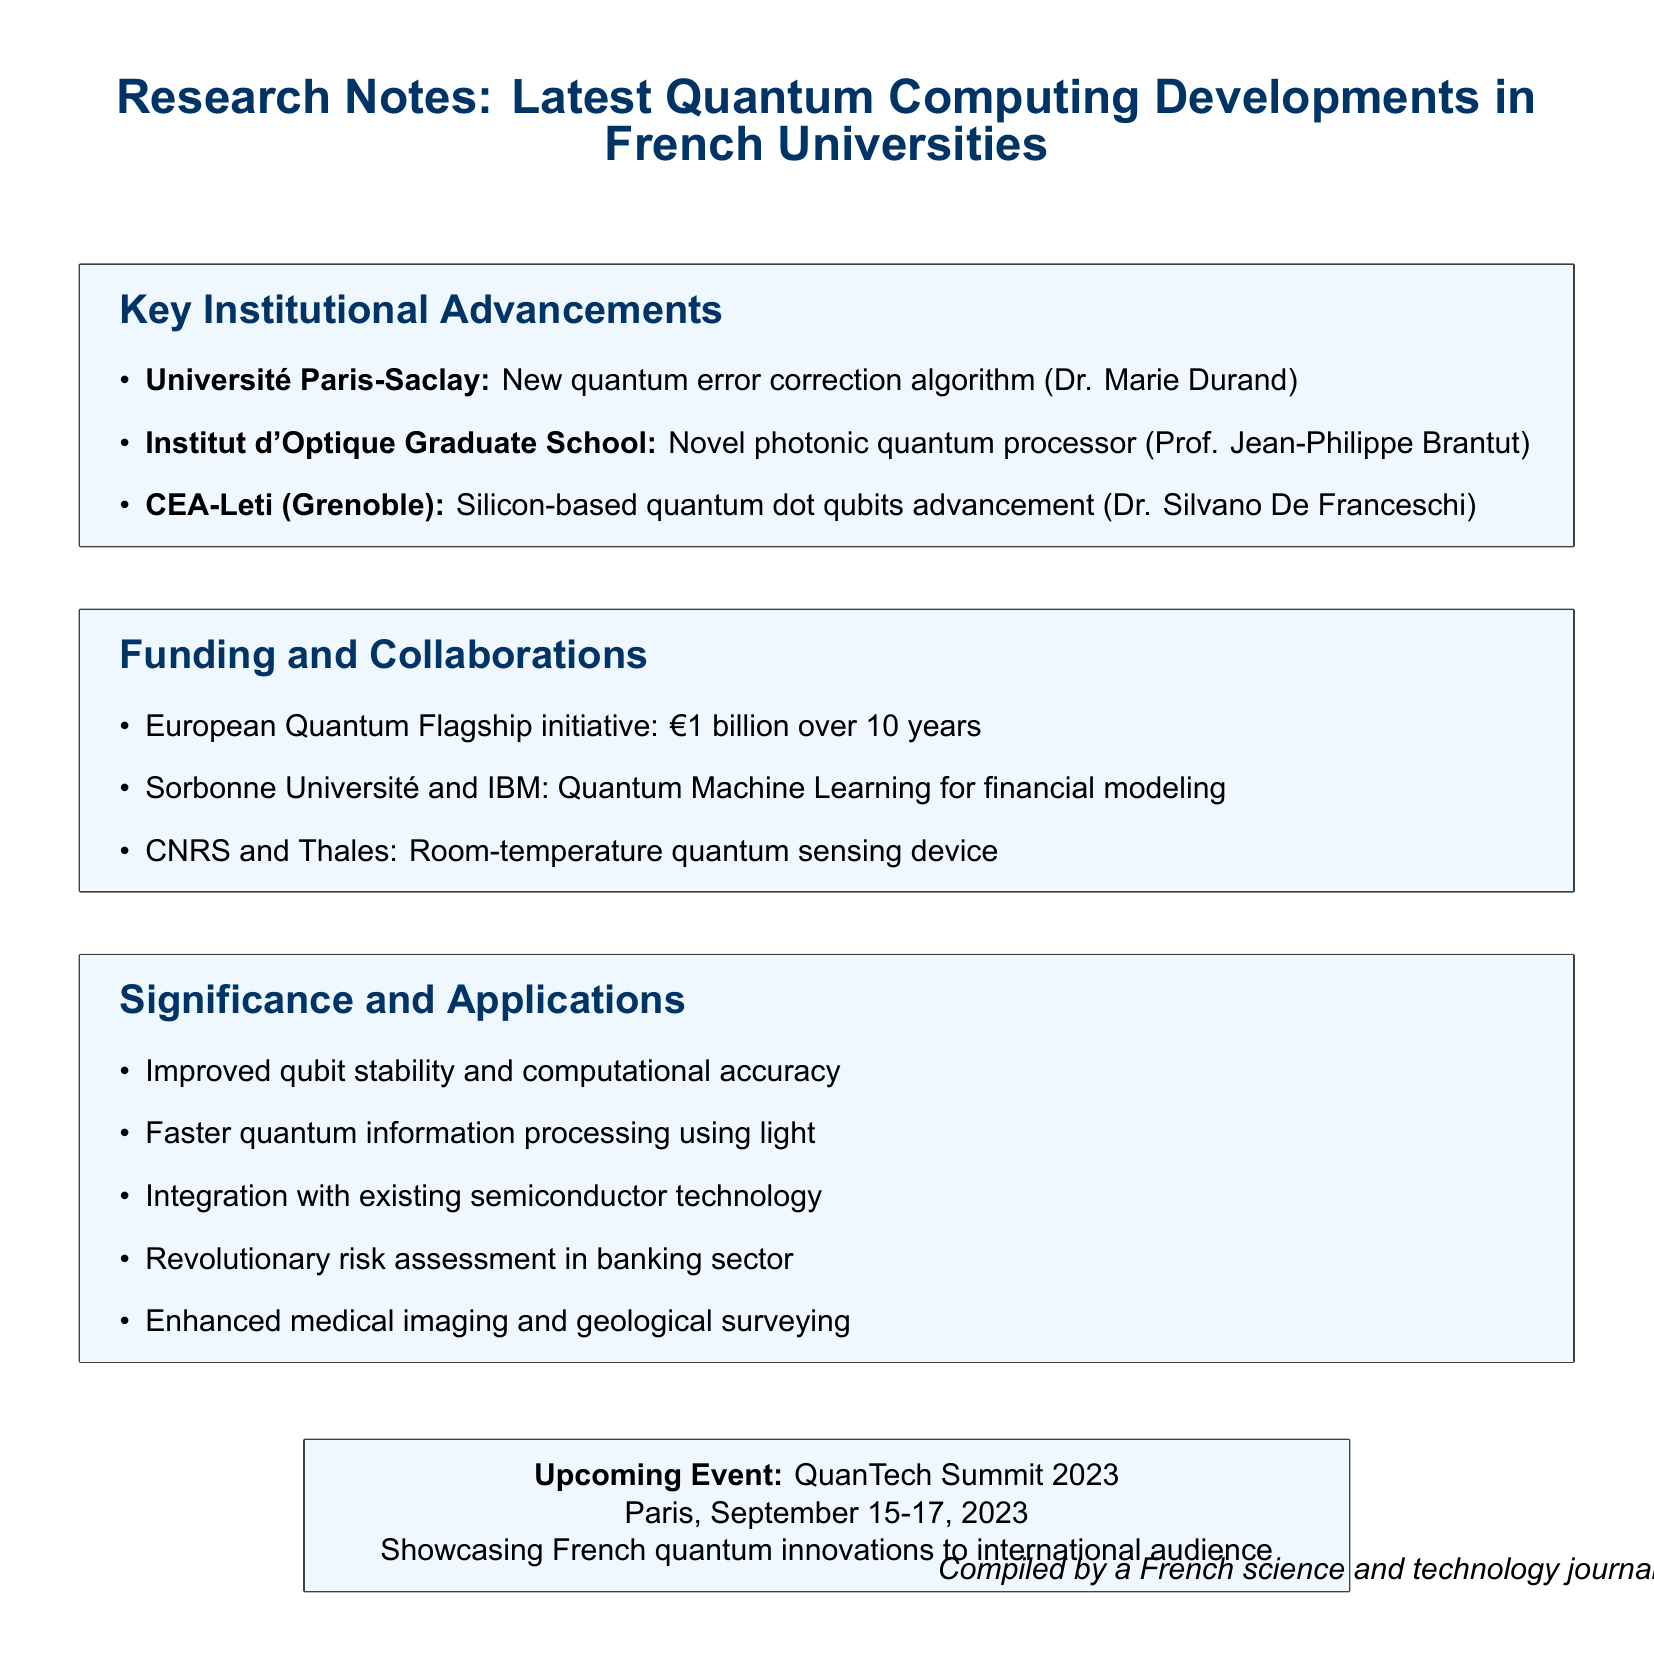What is the research focus of Université Paris-Saclay? The document states that Université Paris-Saclay is focused on the development of a new quantum error correction algorithm.
Answer: new quantum error correction algorithm Who is the lead researcher at Institut d'Optique Graduate School? The key point mentions that Prof. Jean-Philippe Brantut is the lead researcher for the novel photonic quantum processor at the Institut d'Optique Graduate School.
Answer: Prof. Jean-Philippe Brantut What significant advancement is reported by CEA-Leti? The document notes that CEA-Leti has advanced in silicon-based quantum dot qubits.
Answer: silicon-based quantum dot qubits How much funding has been allocated by the European Quantum Flagship initiative? According to the document, the European Quantum Flagship initiative has allocated €1 billion over 10 years.
Answer: €1 billion over 10 years What potential application is mentioned for the collaboration between Sorbonne Université and IBM? The document indicates that the collaboration is focused on Quantum Machine Learning algorithms for financial modeling, which could revolutionize risk assessment in the banking sector.
Answer: Revolutionizing risk assessment in the banking sector What is the upcoming event highlighted in the document? The document mentions the QuanTech Summit 2023 as the upcoming event showcasing French quantum innovations.
Answer: QuanTech Summit 2023 When is the QuanTech Summit taking place? The document provides the date for the QuanTech Summit 2023, which is September 15-17, 2023.
Answer: September 15-17, 2023 Which institutions collaborated on the room-temperature quantum sensing device? The document specifies that CNRS and Thales collaborated on the development of a room-temperature quantum sensing device.
Answer: CNRS and Thales What is one of the key implications of the research developments mentioned in the document? The document highlights the potential for faster quantum information processing using light as one of the key implications.
Answer: Faster quantum information processing using light 